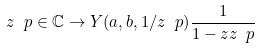Convert formula to latex. <formula><loc_0><loc_0><loc_500><loc_500>z \ p \in \mathbb { C } \to Y ( a , b , 1 / z \ p ) \frac { 1 } { 1 - z z \ p }</formula> 